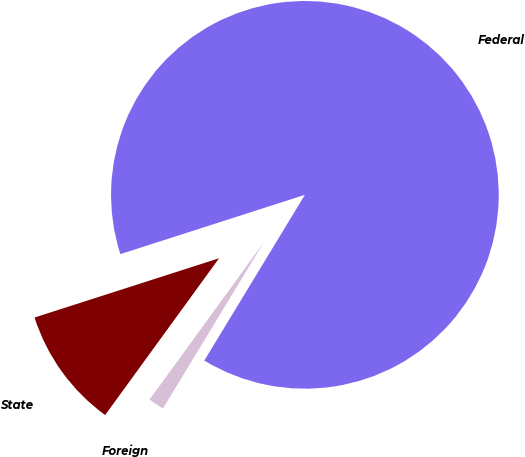<chart> <loc_0><loc_0><loc_500><loc_500><pie_chart><fcel>Federal<fcel>State<fcel>Foreign<nl><fcel>88.62%<fcel>10.05%<fcel>1.32%<nl></chart> 